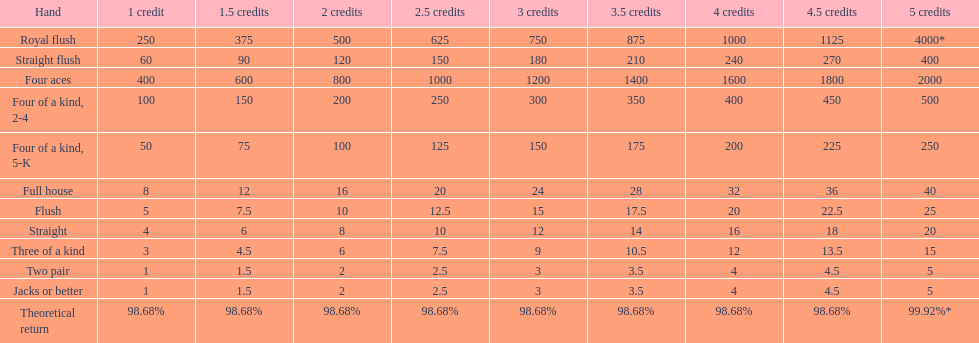What is the amount of credits received for a one credit wager on a royal flush? 250. 